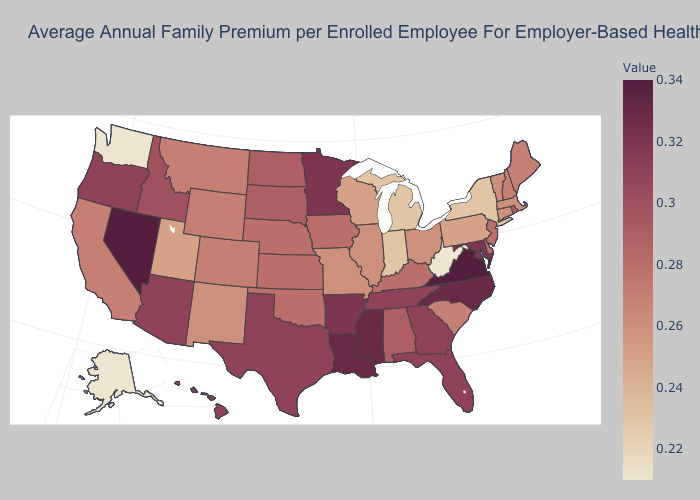Which states have the lowest value in the Northeast?
Write a very short answer. New York. Is the legend a continuous bar?
Short answer required. Yes. Does the map have missing data?
Be succinct. No. Which states have the highest value in the USA?
Be succinct. Nevada, Virginia. Does the map have missing data?
Keep it brief. No. 